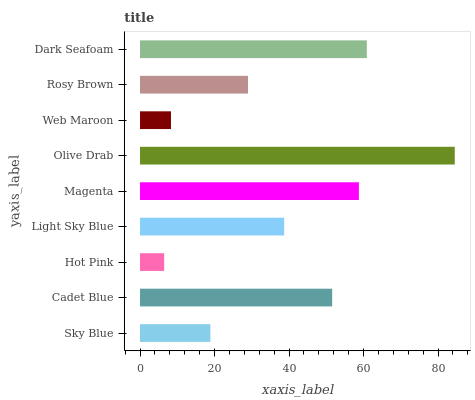Is Hot Pink the minimum?
Answer yes or no. Yes. Is Olive Drab the maximum?
Answer yes or no. Yes. Is Cadet Blue the minimum?
Answer yes or no. No. Is Cadet Blue the maximum?
Answer yes or no. No. Is Cadet Blue greater than Sky Blue?
Answer yes or no. Yes. Is Sky Blue less than Cadet Blue?
Answer yes or no. Yes. Is Sky Blue greater than Cadet Blue?
Answer yes or no. No. Is Cadet Blue less than Sky Blue?
Answer yes or no. No. Is Light Sky Blue the high median?
Answer yes or no. Yes. Is Light Sky Blue the low median?
Answer yes or no. Yes. Is Web Maroon the high median?
Answer yes or no. No. Is Magenta the low median?
Answer yes or no. No. 